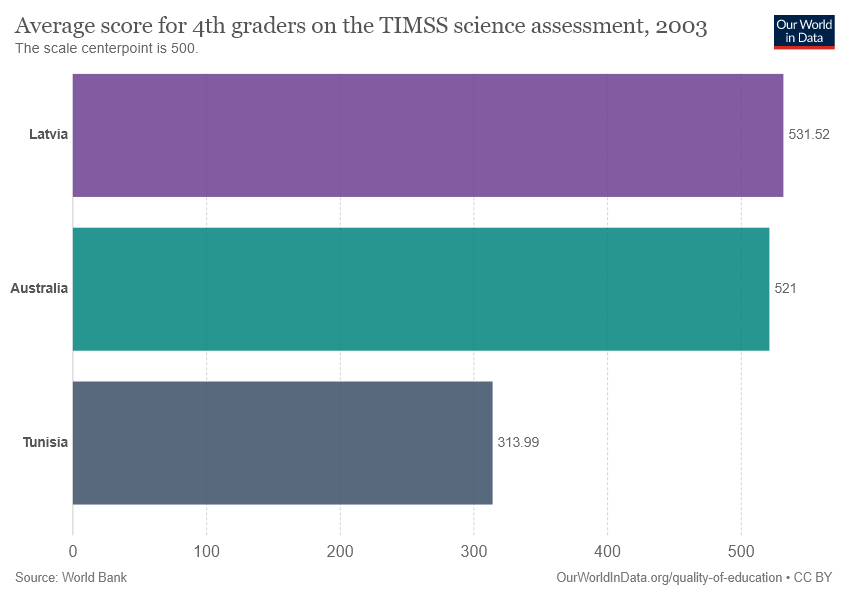Give some essential details in this illustration. The average score of Australia and Tunisia is being added, and then the result is being divided by the average score of Latvia. The final value is 1.57. The bars Latvia and Australia have very close values. 